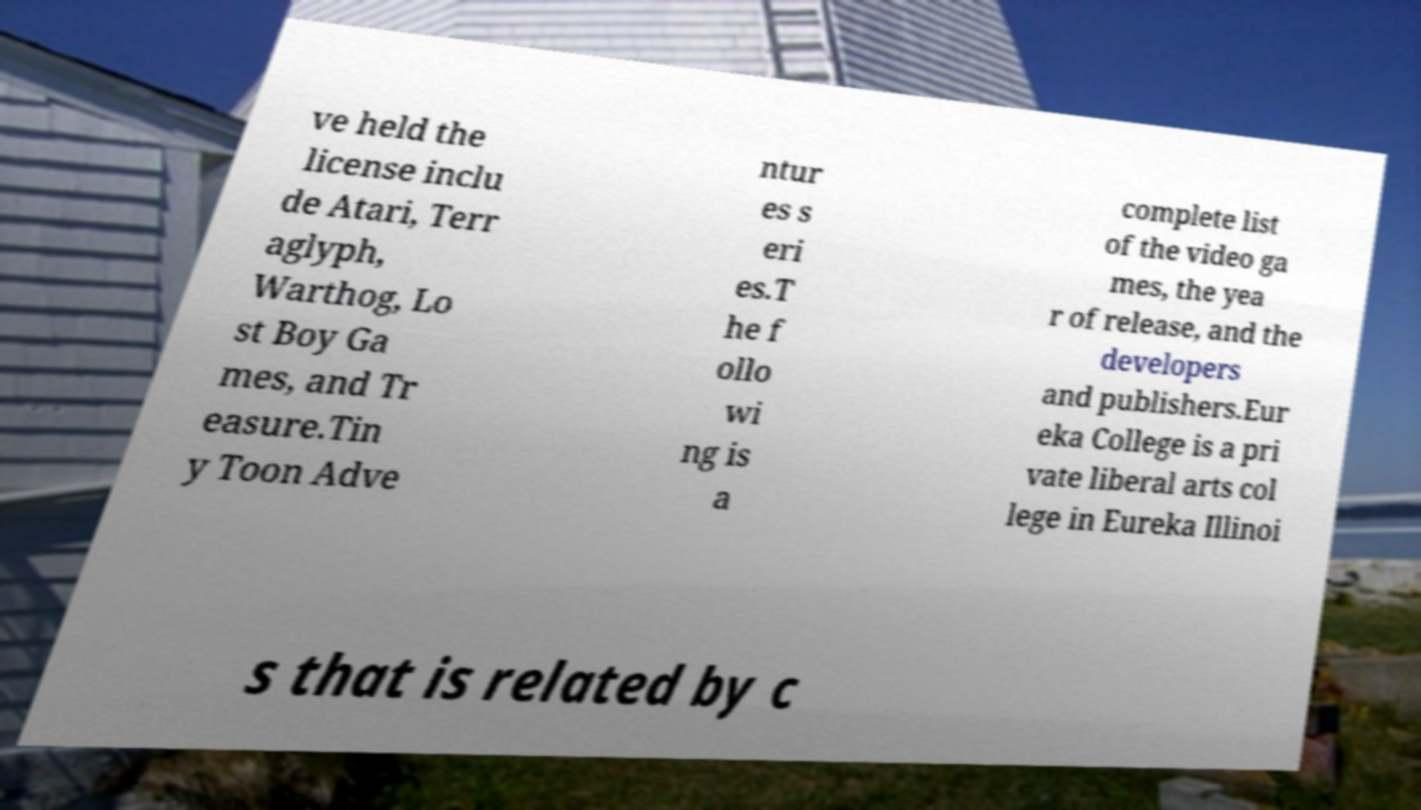Please identify and transcribe the text found in this image. ve held the license inclu de Atari, Terr aglyph, Warthog, Lo st Boy Ga mes, and Tr easure.Tin y Toon Adve ntur es s eri es.T he f ollo wi ng is a complete list of the video ga mes, the yea r of release, and the developers and publishers.Eur eka College is a pri vate liberal arts col lege in Eureka Illinoi s that is related by c 